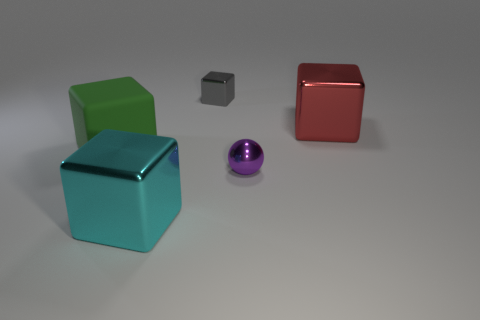Add 2 red metal blocks. How many objects exist? 7 Subtract all blocks. How many objects are left? 1 Subtract all small blue metal cylinders. Subtract all small metal blocks. How many objects are left? 4 Add 5 small things. How many small things are left? 7 Add 2 purple things. How many purple things exist? 3 Subtract 0 blue cubes. How many objects are left? 5 